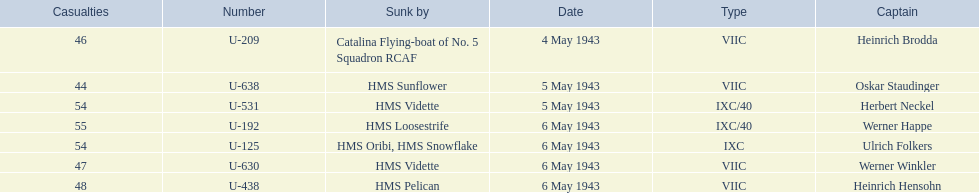Who are all of the captains? Heinrich Brodda, Oskar Staudinger, Herbert Neckel, Werner Happe, Ulrich Folkers, Werner Winkler, Heinrich Hensohn. What sunk each of the captains? Catalina Flying-boat of No. 5 Squadron RCAF, HMS Sunflower, HMS Vidette, HMS Loosestrife, HMS Oribi, HMS Snowflake, HMS Vidette, HMS Pelican. Which was sunk by the hms pelican? Heinrich Hensohn. 